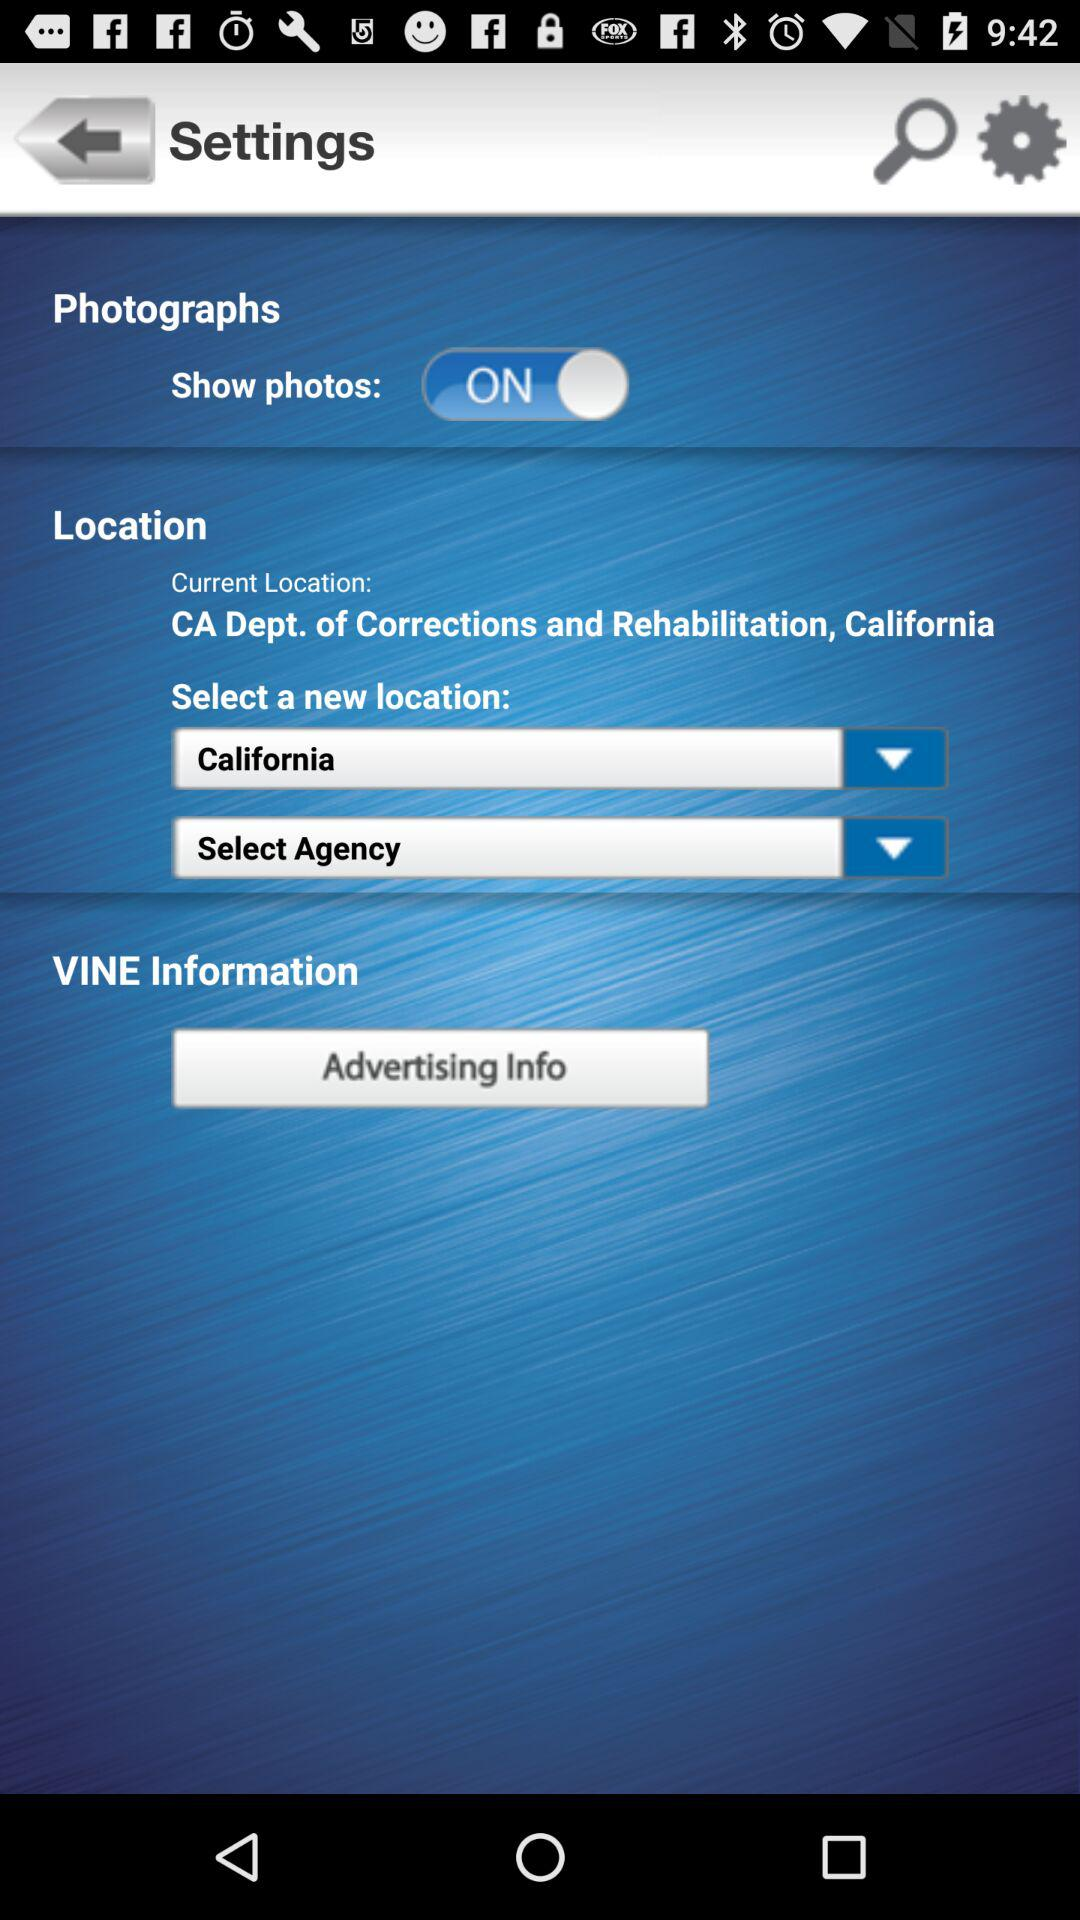What is the selected location? The selected location is California. 